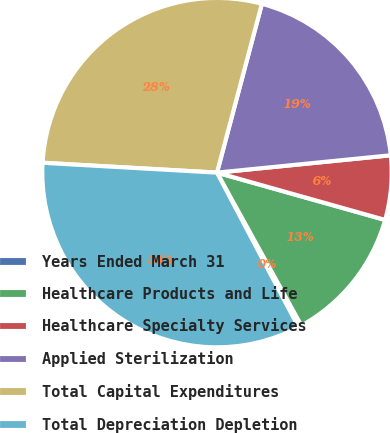Convert chart to OTSL. <chart><loc_0><loc_0><loc_500><loc_500><pie_chart><fcel>Years Ended March 31<fcel>Healthcare Products and Life<fcel>Healthcare Specialty Services<fcel>Applied Sterilization<fcel>Total Capital Expenditures<fcel>Total Depreciation Depletion<nl><fcel>0.3%<fcel>12.61%<fcel>5.95%<fcel>19.28%<fcel>28.24%<fcel>33.63%<nl></chart> 